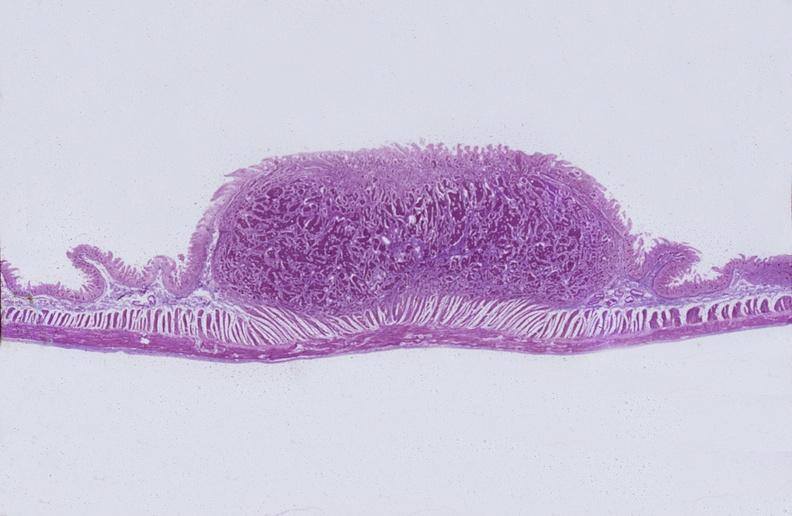where is this from?
Answer the question using a single word or phrase. Gastrointestinal system 